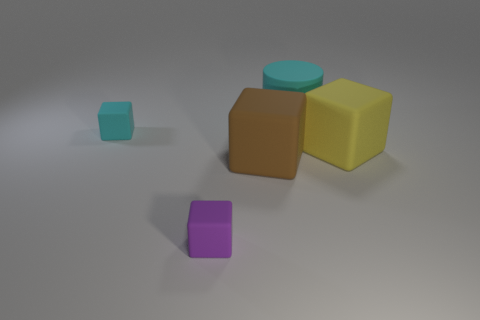What size is the block that is both to the right of the purple matte object and to the left of the big cyan cylinder?
Give a very brief answer. Large. What shape is the rubber thing that is to the right of the small purple thing and behind the large yellow rubber object?
Your answer should be very brief. Cylinder. Is there a brown object that is in front of the tiny rubber cube that is right of the tiny thing behind the purple matte block?
Give a very brief answer. No. What number of objects are big cyan objects right of the big brown cube or blocks that are to the left of the brown rubber block?
Ensure brevity in your answer.  3. Is the material of the small cube that is on the right side of the tiny cyan matte thing the same as the cyan block?
Your answer should be compact. Yes. There is a big thing that is both to the left of the large yellow rubber thing and behind the brown object; what is it made of?
Provide a short and direct response. Rubber. What color is the matte thing on the left side of the tiny matte object that is on the right side of the cyan block?
Keep it short and to the point. Cyan. What material is the yellow object that is the same shape as the tiny purple rubber thing?
Provide a succinct answer. Rubber. There is a small thing right of the tiny block that is behind the tiny thing in front of the large yellow block; what is its color?
Your response must be concise. Purple. How many things are either large gray matte balls or brown things?
Make the answer very short. 1. 